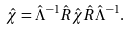Convert formula to latex. <formula><loc_0><loc_0><loc_500><loc_500>\hat { \chi } = \hat { \Lambda } ^ { - 1 } \hat { R } \hat { \chi } \hat { R } \hat { \Lambda } ^ { - 1 } .</formula> 